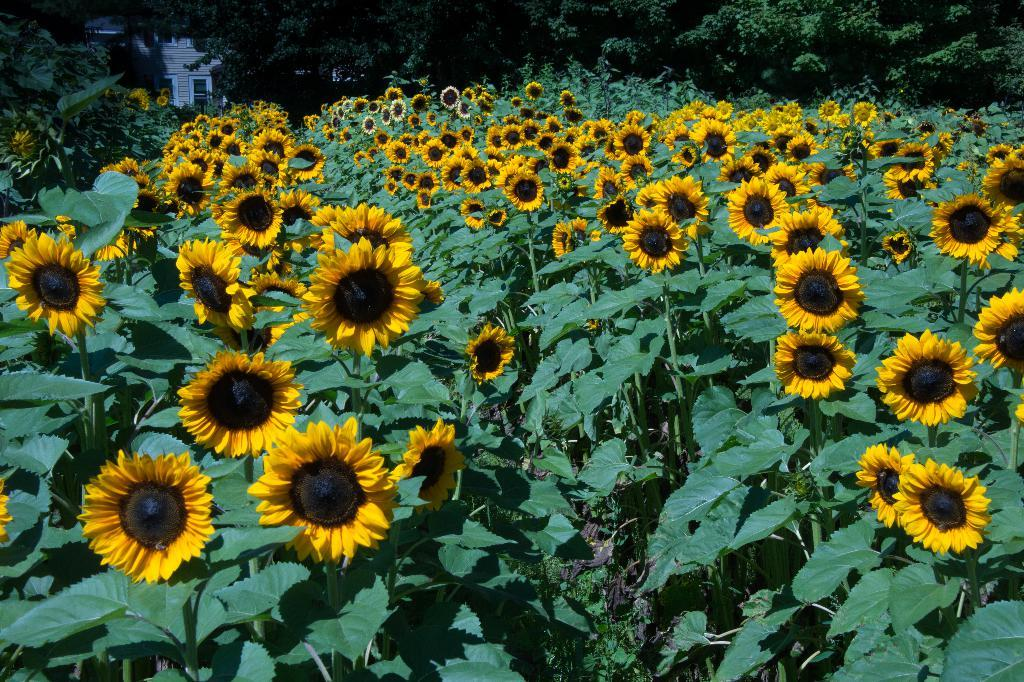What type of plants can be seen in the image? There are plants with flowers in the image. What is visible in the background of the image? There is a building and trees in the background of the image. What type of credit can be seen on the plants in the image? There is no credit present on the plants in the image; they are simply plants with flowers. 